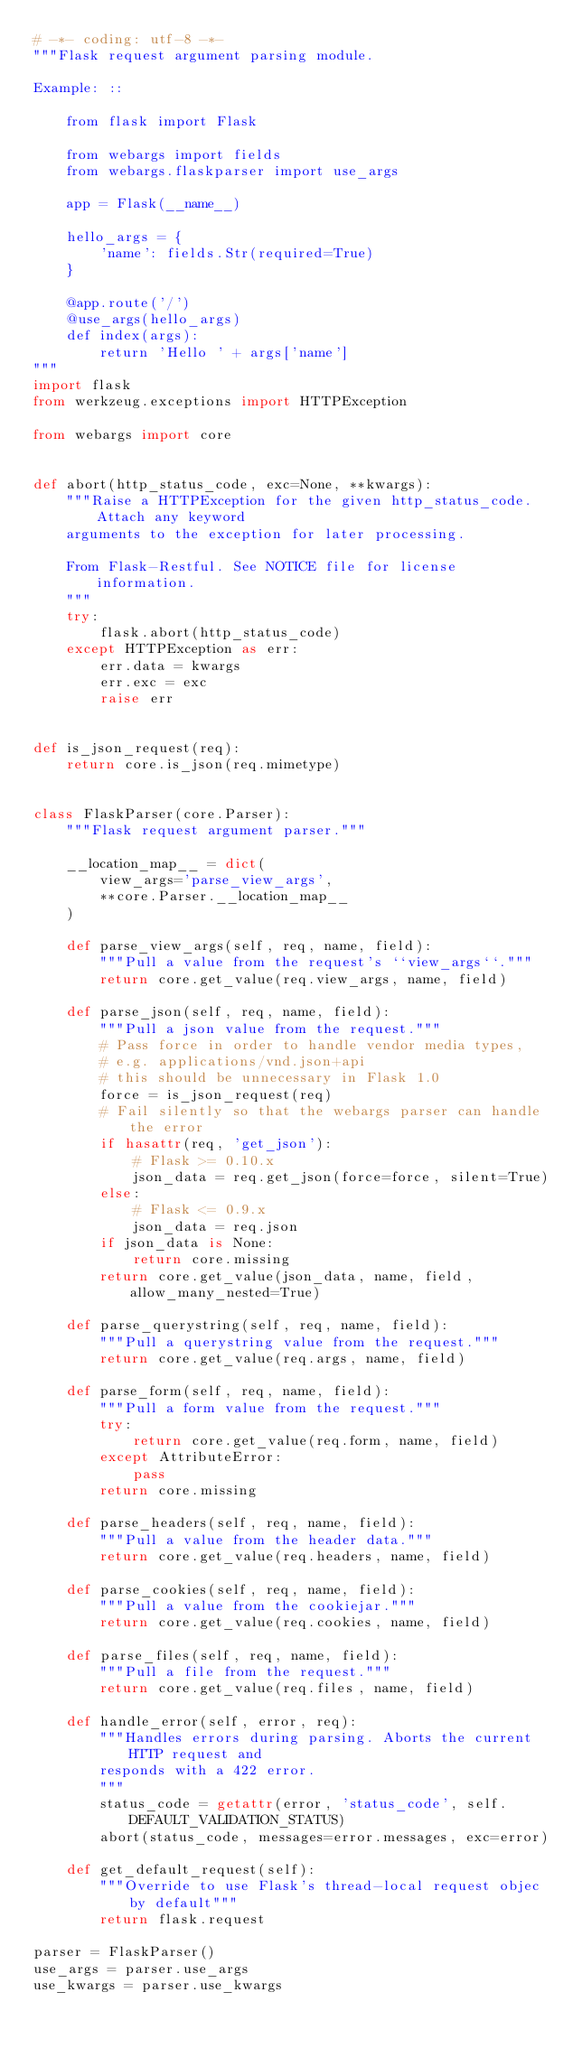Convert code to text. <code><loc_0><loc_0><loc_500><loc_500><_Python_># -*- coding: utf-8 -*-
"""Flask request argument parsing module.

Example: ::

    from flask import Flask

    from webargs import fields
    from webargs.flaskparser import use_args

    app = Flask(__name__)

    hello_args = {
        'name': fields.Str(required=True)
    }

    @app.route('/')
    @use_args(hello_args)
    def index(args):
        return 'Hello ' + args['name']
"""
import flask
from werkzeug.exceptions import HTTPException

from webargs import core


def abort(http_status_code, exc=None, **kwargs):
    """Raise a HTTPException for the given http_status_code. Attach any keyword
    arguments to the exception for later processing.

    From Flask-Restful. See NOTICE file for license information.
    """
    try:
        flask.abort(http_status_code)
    except HTTPException as err:
        err.data = kwargs
        err.exc = exc
        raise err


def is_json_request(req):
    return core.is_json(req.mimetype)


class FlaskParser(core.Parser):
    """Flask request argument parser."""

    __location_map__ = dict(
        view_args='parse_view_args',
        **core.Parser.__location_map__
    )

    def parse_view_args(self, req, name, field):
        """Pull a value from the request's ``view_args``."""
        return core.get_value(req.view_args, name, field)

    def parse_json(self, req, name, field):
        """Pull a json value from the request."""
        # Pass force in order to handle vendor media types,
        # e.g. applications/vnd.json+api
        # this should be unnecessary in Flask 1.0
        force = is_json_request(req)
        # Fail silently so that the webargs parser can handle the error
        if hasattr(req, 'get_json'):
            # Flask >= 0.10.x
            json_data = req.get_json(force=force, silent=True)
        else:
            # Flask <= 0.9.x
            json_data = req.json
        if json_data is None:
            return core.missing
        return core.get_value(json_data, name, field, allow_many_nested=True)

    def parse_querystring(self, req, name, field):
        """Pull a querystring value from the request."""
        return core.get_value(req.args, name, field)

    def parse_form(self, req, name, field):
        """Pull a form value from the request."""
        try:
            return core.get_value(req.form, name, field)
        except AttributeError:
            pass
        return core.missing

    def parse_headers(self, req, name, field):
        """Pull a value from the header data."""
        return core.get_value(req.headers, name, field)

    def parse_cookies(self, req, name, field):
        """Pull a value from the cookiejar."""
        return core.get_value(req.cookies, name, field)

    def parse_files(self, req, name, field):
        """Pull a file from the request."""
        return core.get_value(req.files, name, field)

    def handle_error(self, error, req):
        """Handles errors during parsing. Aborts the current HTTP request and
        responds with a 422 error.
        """
        status_code = getattr(error, 'status_code', self.DEFAULT_VALIDATION_STATUS)
        abort(status_code, messages=error.messages, exc=error)

    def get_default_request(self):
        """Override to use Flask's thread-local request objec by default"""
        return flask.request

parser = FlaskParser()
use_args = parser.use_args
use_kwargs = parser.use_kwargs
</code> 